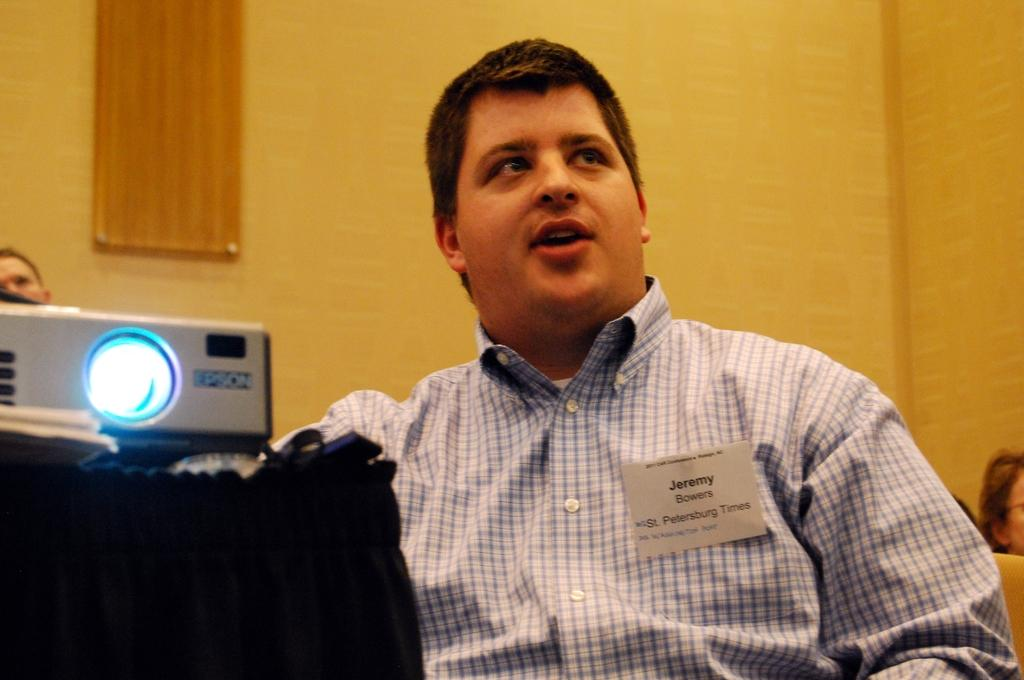Who or what is the main subject in the image? There is a person in the center of the image. What can be seen behind the person in the image? There is a wall in the background of the image. What type of grass is growing on the person's head in the image? There is no grass visible on the person's head in the image. What kind of substance is the person holding in the image? The provided facts do not mention any substance being held by the person in the image. 